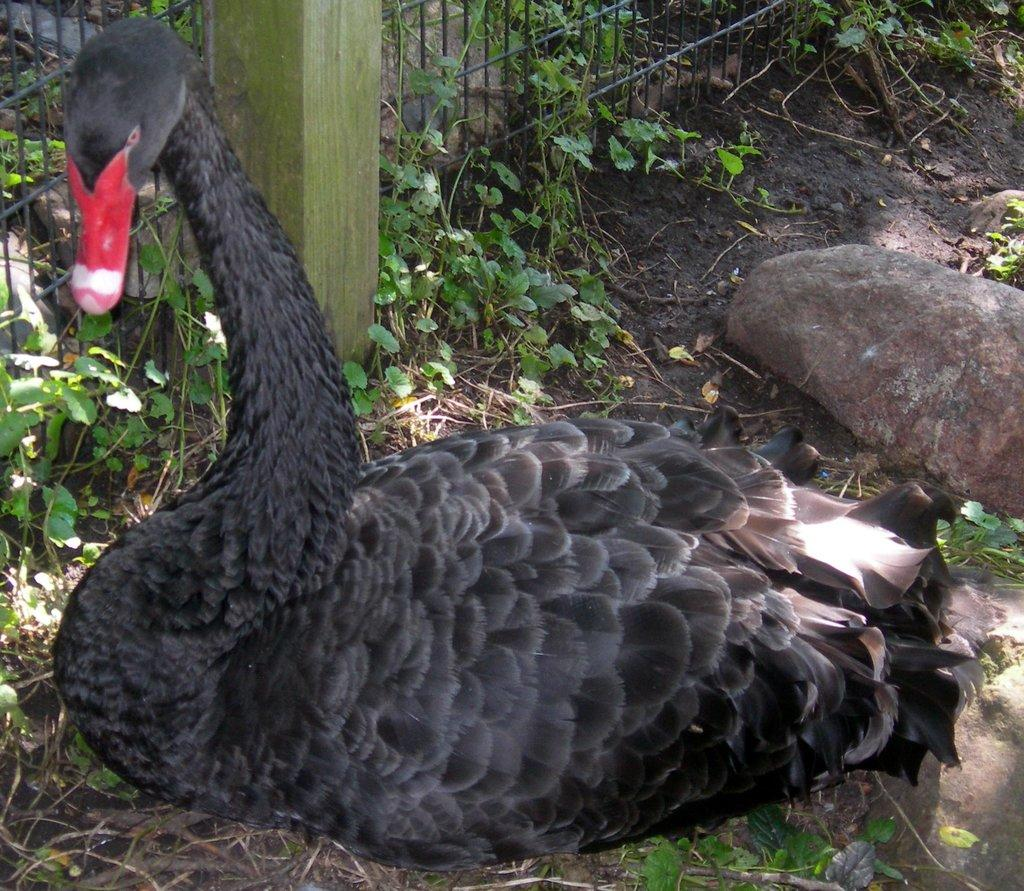What type of animal is in the image? There is a black swan in the image. Where is the swan located? The swan is on the grass. What can be seen in the background of the image? There are plants, rocks, and a wire fence in the background of the image. What type of calculator is the swan using in the image? There is no calculator present in the image; it features a black swan on the grass. What account does the swan have with the nearby bank in the image? There is no bank or account mentioned in the image; it only shows a black swan on the grass and the background elements. 